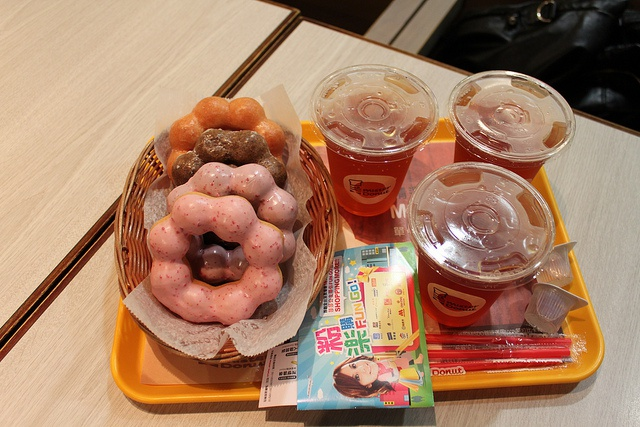Describe the objects in this image and their specific colors. I can see dining table in tan, darkgray, brown, and maroon tones, dining table in tan, maroon, and brown tones, cup in tan, gray, maroon, and brown tones, cup in tan, salmon, and maroon tones, and donut in tan, brown, and salmon tones in this image. 